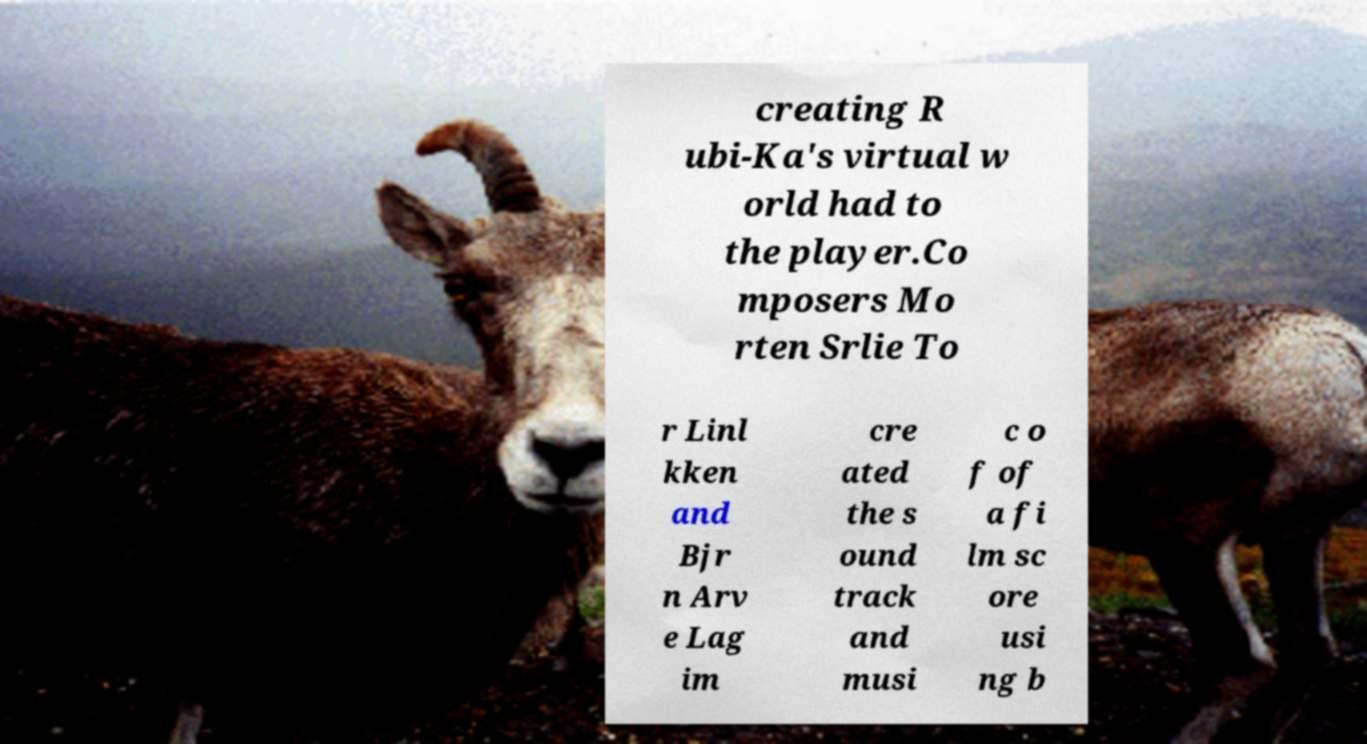Can you read and provide the text displayed in the image?This photo seems to have some interesting text. Can you extract and type it out for me? creating R ubi-Ka's virtual w orld had to the player.Co mposers Mo rten Srlie To r Linl kken and Bjr n Arv e Lag im cre ated the s ound track and musi c o f of a fi lm sc ore usi ng b 